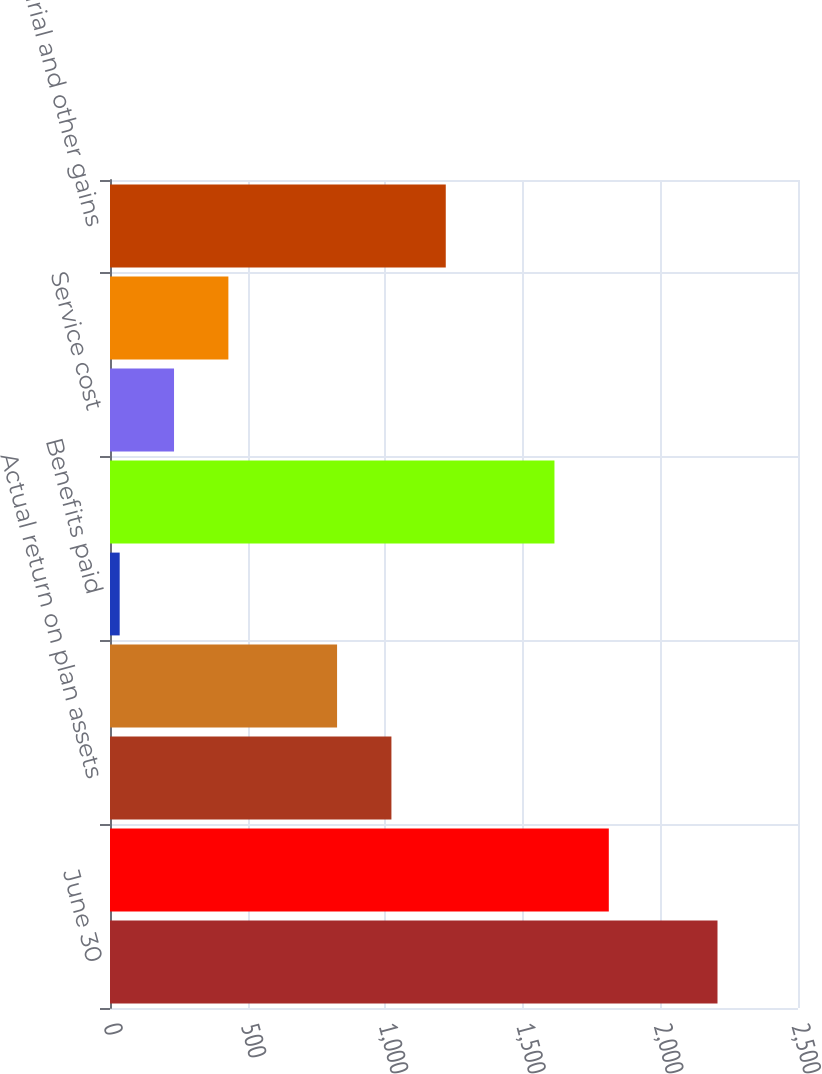<chart> <loc_0><loc_0><loc_500><loc_500><bar_chart><fcel>June 30<fcel>Fair value of plan assets at<fcel>Actual return on plan assets<fcel>Employer contributions<fcel>Benefits paid<fcel>Benefit obligation at<fcel>Service cost<fcel>Interest cost<fcel>Actuarial and other gains<nl><fcel>2207.48<fcel>1812.52<fcel>1022.6<fcel>825.12<fcel>35.2<fcel>1615.04<fcel>232.68<fcel>430.16<fcel>1220.08<nl></chart> 